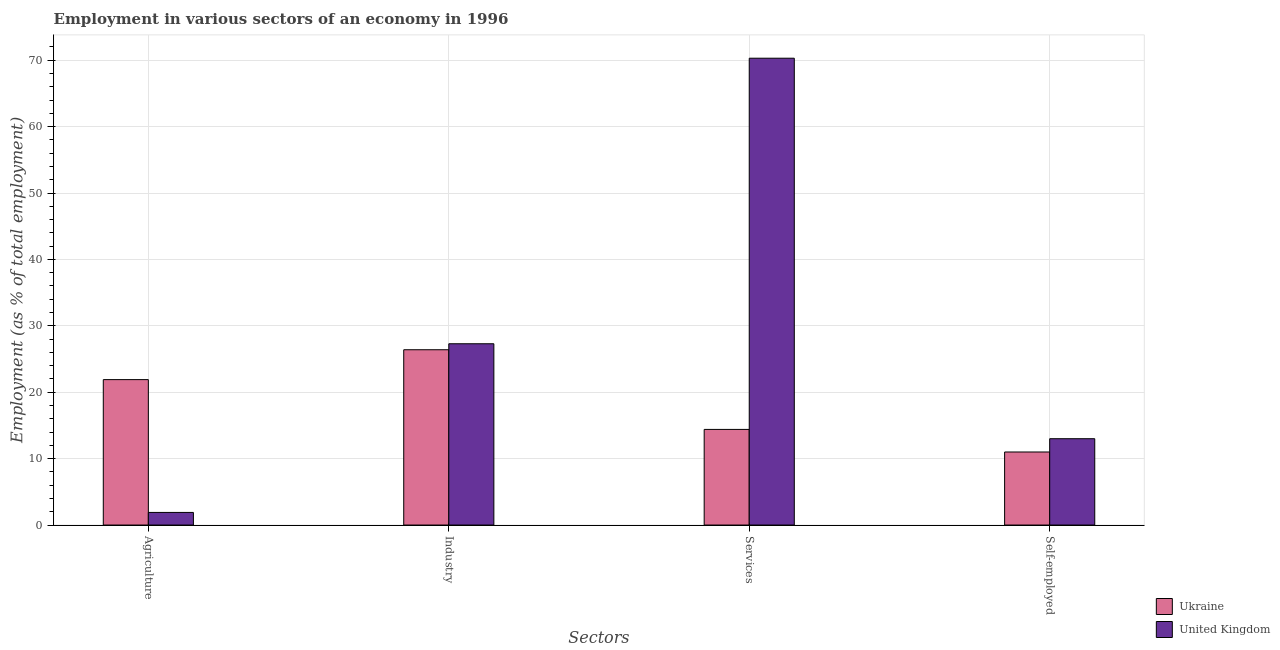How many different coloured bars are there?
Keep it short and to the point. 2. How many bars are there on the 1st tick from the right?
Offer a terse response. 2. What is the label of the 1st group of bars from the left?
Your answer should be compact. Agriculture. What is the percentage of workers in services in United Kingdom?
Your answer should be compact. 70.3. Across all countries, what is the maximum percentage of workers in services?
Offer a terse response. 70.3. In which country was the percentage of self employed workers maximum?
Give a very brief answer. United Kingdom. What is the total percentage of workers in industry in the graph?
Give a very brief answer. 53.7. What is the difference between the percentage of self employed workers in United Kingdom and that in Ukraine?
Your response must be concise. 2. What is the difference between the percentage of workers in agriculture in Ukraine and the percentage of workers in services in United Kingdom?
Offer a terse response. -48.4. What is the average percentage of workers in agriculture per country?
Ensure brevity in your answer.  11.9. What is the difference between the percentage of workers in services and percentage of self employed workers in Ukraine?
Provide a short and direct response. 3.4. What is the ratio of the percentage of workers in services in United Kingdom to that in Ukraine?
Make the answer very short. 4.88. What is the difference between the highest and the second highest percentage of workers in services?
Make the answer very short. 55.9. What is the difference between the highest and the lowest percentage of workers in services?
Offer a very short reply. 55.9. In how many countries, is the percentage of self employed workers greater than the average percentage of self employed workers taken over all countries?
Ensure brevity in your answer.  1. What does the 1st bar from the left in Agriculture represents?
Keep it short and to the point. Ukraine. Is it the case that in every country, the sum of the percentage of workers in agriculture and percentage of workers in industry is greater than the percentage of workers in services?
Provide a succinct answer. No. Are all the bars in the graph horizontal?
Offer a very short reply. No. How many countries are there in the graph?
Offer a very short reply. 2. What is the difference between two consecutive major ticks on the Y-axis?
Make the answer very short. 10. Are the values on the major ticks of Y-axis written in scientific E-notation?
Offer a very short reply. No. Does the graph contain any zero values?
Your response must be concise. No. Does the graph contain grids?
Keep it short and to the point. Yes. Where does the legend appear in the graph?
Provide a short and direct response. Bottom right. How many legend labels are there?
Ensure brevity in your answer.  2. What is the title of the graph?
Provide a short and direct response. Employment in various sectors of an economy in 1996. Does "China" appear as one of the legend labels in the graph?
Keep it short and to the point. No. What is the label or title of the X-axis?
Keep it short and to the point. Sectors. What is the label or title of the Y-axis?
Your answer should be compact. Employment (as % of total employment). What is the Employment (as % of total employment) in Ukraine in Agriculture?
Give a very brief answer. 21.9. What is the Employment (as % of total employment) of United Kingdom in Agriculture?
Your answer should be compact. 1.9. What is the Employment (as % of total employment) of Ukraine in Industry?
Give a very brief answer. 26.4. What is the Employment (as % of total employment) of United Kingdom in Industry?
Offer a terse response. 27.3. What is the Employment (as % of total employment) in Ukraine in Services?
Offer a terse response. 14.4. What is the Employment (as % of total employment) of United Kingdom in Services?
Offer a very short reply. 70.3. What is the Employment (as % of total employment) of Ukraine in Self-employed?
Give a very brief answer. 11. Across all Sectors, what is the maximum Employment (as % of total employment) of Ukraine?
Your response must be concise. 26.4. Across all Sectors, what is the maximum Employment (as % of total employment) in United Kingdom?
Offer a very short reply. 70.3. Across all Sectors, what is the minimum Employment (as % of total employment) of Ukraine?
Your response must be concise. 11. Across all Sectors, what is the minimum Employment (as % of total employment) in United Kingdom?
Provide a succinct answer. 1.9. What is the total Employment (as % of total employment) of Ukraine in the graph?
Keep it short and to the point. 73.7. What is the total Employment (as % of total employment) in United Kingdom in the graph?
Ensure brevity in your answer.  112.5. What is the difference between the Employment (as % of total employment) in United Kingdom in Agriculture and that in Industry?
Make the answer very short. -25.4. What is the difference between the Employment (as % of total employment) of United Kingdom in Agriculture and that in Services?
Provide a succinct answer. -68.4. What is the difference between the Employment (as % of total employment) of United Kingdom in Agriculture and that in Self-employed?
Your answer should be compact. -11.1. What is the difference between the Employment (as % of total employment) in Ukraine in Industry and that in Services?
Your answer should be very brief. 12. What is the difference between the Employment (as % of total employment) in United Kingdom in Industry and that in Services?
Give a very brief answer. -43. What is the difference between the Employment (as % of total employment) of Ukraine in Industry and that in Self-employed?
Give a very brief answer. 15.4. What is the difference between the Employment (as % of total employment) in United Kingdom in Services and that in Self-employed?
Offer a very short reply. 57.3. What is the difference between the Employment (as % of total employment) of Ukraine in Agriculture and the Employment (as % of total employment) of United Kingdom in Industry?
Your response must be concise. -5.4. What is the difference between the Employment (as % of total employment) of Ukraine in Agriculture and the Employment (as % of total employment) of United Kingdom in Services?
Your answer should be very brief. -48.4. What is the difference between the Employment (as % of total employment) in Ukraine in Industry and the Employment (as % of total employment) in United Kingdom in Services?
Provide a succinct answer. -43.9. What is the difference between the Employment (as % of total employment) of Ukraine in Industry and the Employment (as % of total employment) of United Kingdom in Self-employed?
Ensure brevity in your answer.  13.4. What is the difference between the Employment (as % of total employment) in Ukraine in Services and the Employment (as % of total employment) in United Kingdom in Self-employed?
Your answer should be compact. 1.4. What is the average Employment (as % of total employment) in Ukraine per Sectors?
Ensure brevity in your answer.  18.43. What is the average Employment (as % of total employment) of United Kingdom per Sectors?
Ensure brevity in your answer.  28.12. What is the difference between the Employment (as % of total employment) in Ukraine and Employment (as % of total employment) in United Kingdom in Services?
Provide a succinct answer. -55.9. What is the ratio of the Employment (as % of total employment) of Ukraine in Agriculture to that in Industry?
Provide a short and direct response. 0.83. What is the ratio of the Employment (as % of total employment) in United Kingdom in Agriculture to that in Industry?
Give a very brief answer. 0.07. What is the ratio of the Employment (as % of total employment) in Ukraine in Agriculture to that in Services?
Keep it short and to the point. 1.52. What is the ratio of the Employment (as % of total employment) in United Kingdom in Agriculture to that in Services?
Your response must be concise. 0.03. What is the ratio of the Employment (as % of total employment) of Ukraine in Agriculture to that in Self-employed?
Your response must be concise. 1.99. What is the ratio of the Employment (as % of total employment) of United Kingdom in Agriculture to that in Self-employed?
Keep it short and to the point. 0.15. What is the ratio of the Employment (as % of total employment) of Ukraine in Industry to that in Services?
Ensure brevity in your answer.  1.83. What is the ratio of the Employment (as % of total employment) in United Kingdom in Industry to that in Services?
Provide a succinct answer. 0.39. What is the ratio of the Employment (as % of total employment) in Ukraine in Industry to that in Self-employed?
Provide a short and direct response. 2.4. What is the ratio of the Employment (as % of total employment) in Ukraine in Services to that in Self-employed?
Your answer should be very brief. 1.31. What is the ratio of the Employment (as % of total employment) in United Kingdom in Services to that in Self-employed?
Offer a terse response. 5.41. What is the difference between the highest and the lowest Employment (as % of total employment) in Ukraine?
Offer a very short reply. 15.4. What is the difference between the highest and the lowest Employment (as % of total employment) in United Kingdom?
Provide a succinct answer. 68.4. 